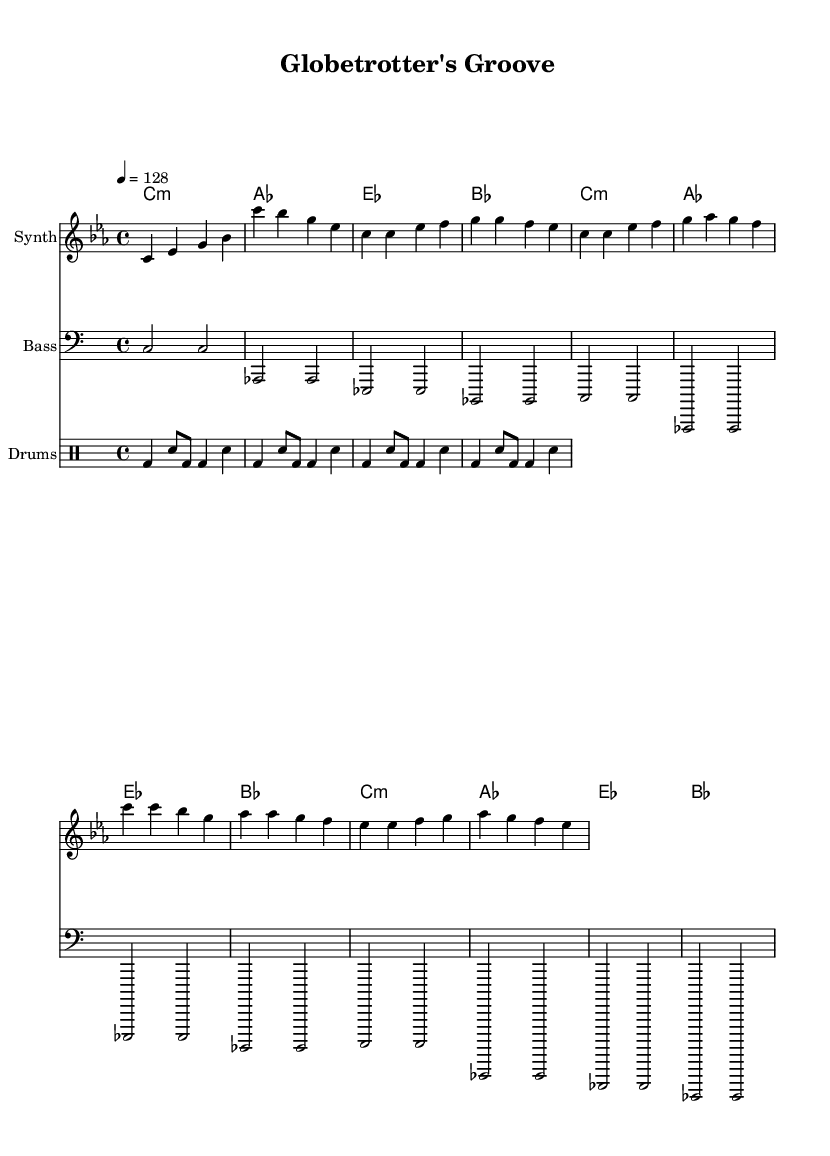what is the key signature of this music? The key signature is C minor, which has three flats (B flat, E flat, A flat). This can be determined by looking at the left side of the staff where the flats are indicated.
Answer: C minor what is the time signature of this music? The time signature is 4/4, which is indicated at the beginning of the staff. This means there are four beats in each measure, and the quarter note receives one beat.
Answer: 4/4 what is the tempo marking of this music? The tempo marking is 128 beats per minute, indicated by "4 = 128" at the beginning of the score. This tells the performer how fast the music should be played.
Answer: 128 how many measures are in the melody section? The melody section includes 8 measures, which can be counted by the total number of vertical bar lines separating the music segments. Each segment between two bar lines represents one measure.
Answer: 8 what chords are used in the first verse of this music? The chord progression in the first verse involves C minor, A flat, E flat, and B flat chords, as shown in the chord mode section that associates with the melody.
Answer: C minor, A flat, E flat, B flat how does the bassline differ from the melody in terms of rhythm? The bassline plays half notes while the melody uses quarter notes, allowing the bass to provide a steady foundation as the melody moves more quickly. This rhythmic contrast can be observed in the respective staff sections illustrating the different note values.
Answer: The bassline uses half notes what is the function of the drum pattern in this piece? The drum pattern contributes to creating a danceable groove, characterized by a combination of bass drum hits and snare on the backbeat, giving the music its rhythmic drive suitable for electronic dance music. This can be analyzed by observing the drum staff where the distinct notes are placed accordingly to create a consistent beat.
Answer: Danceable groove 